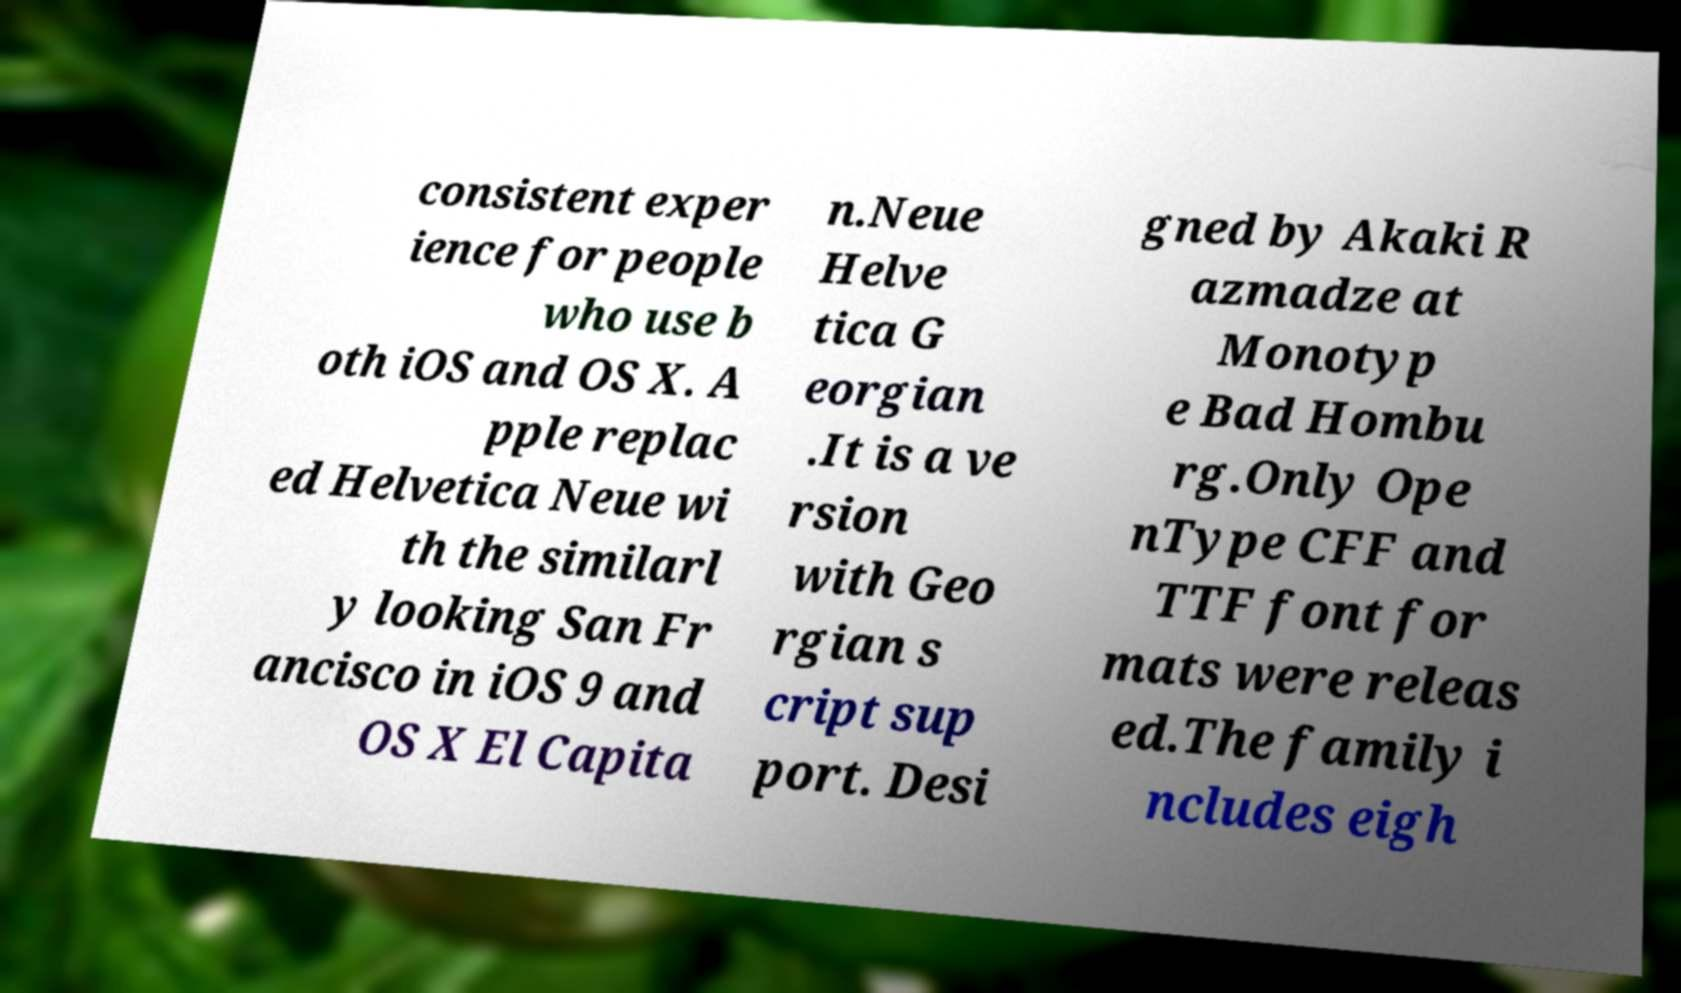Could you assist in decoding the text presented in this image and type it out clearly? consistent exper ience for people who use b oth iOS and OS X. A pple replac ed Helvetica Neue wi th the similarl y looking San Fr ancisco in iOS 9 and OS X El Capita n.Neue Helve tica G eorgian .It is a ve rsion with Geo rgian s cript sup port. Desi gned by Akaki R azmadze at Monotyp e Bad Hombu rg.Only Ope nType CFF and TTF font for mats were releas ed.The family i ncludes eigh 